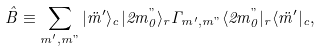Convert formula to latex. <formula><loc_0><loc_0><loc_500><loc_500>\hat { B } \equiv \sum _ { m ^ { \prime } , m " } | \ddot { m } { ^ { \prime } } \rangle _ { c } | 2 m _ { 0 } ^ { " } \rangle _ { r } \Gamma _ { m ^ { \prime } , m " } \langle 2 m _ { 0 } ^ { " } | _ { r } \langle \ddot { m } { ^ { \prime } } | _ { c } ,</formula> 